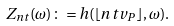<formula> <loc_0><loc_0><loc_500><loc_500>Z _ { n t } ( \omega ) \colon = h ( \lfloor n t v _ { P } \rfloor , \omega ) .</formula> 